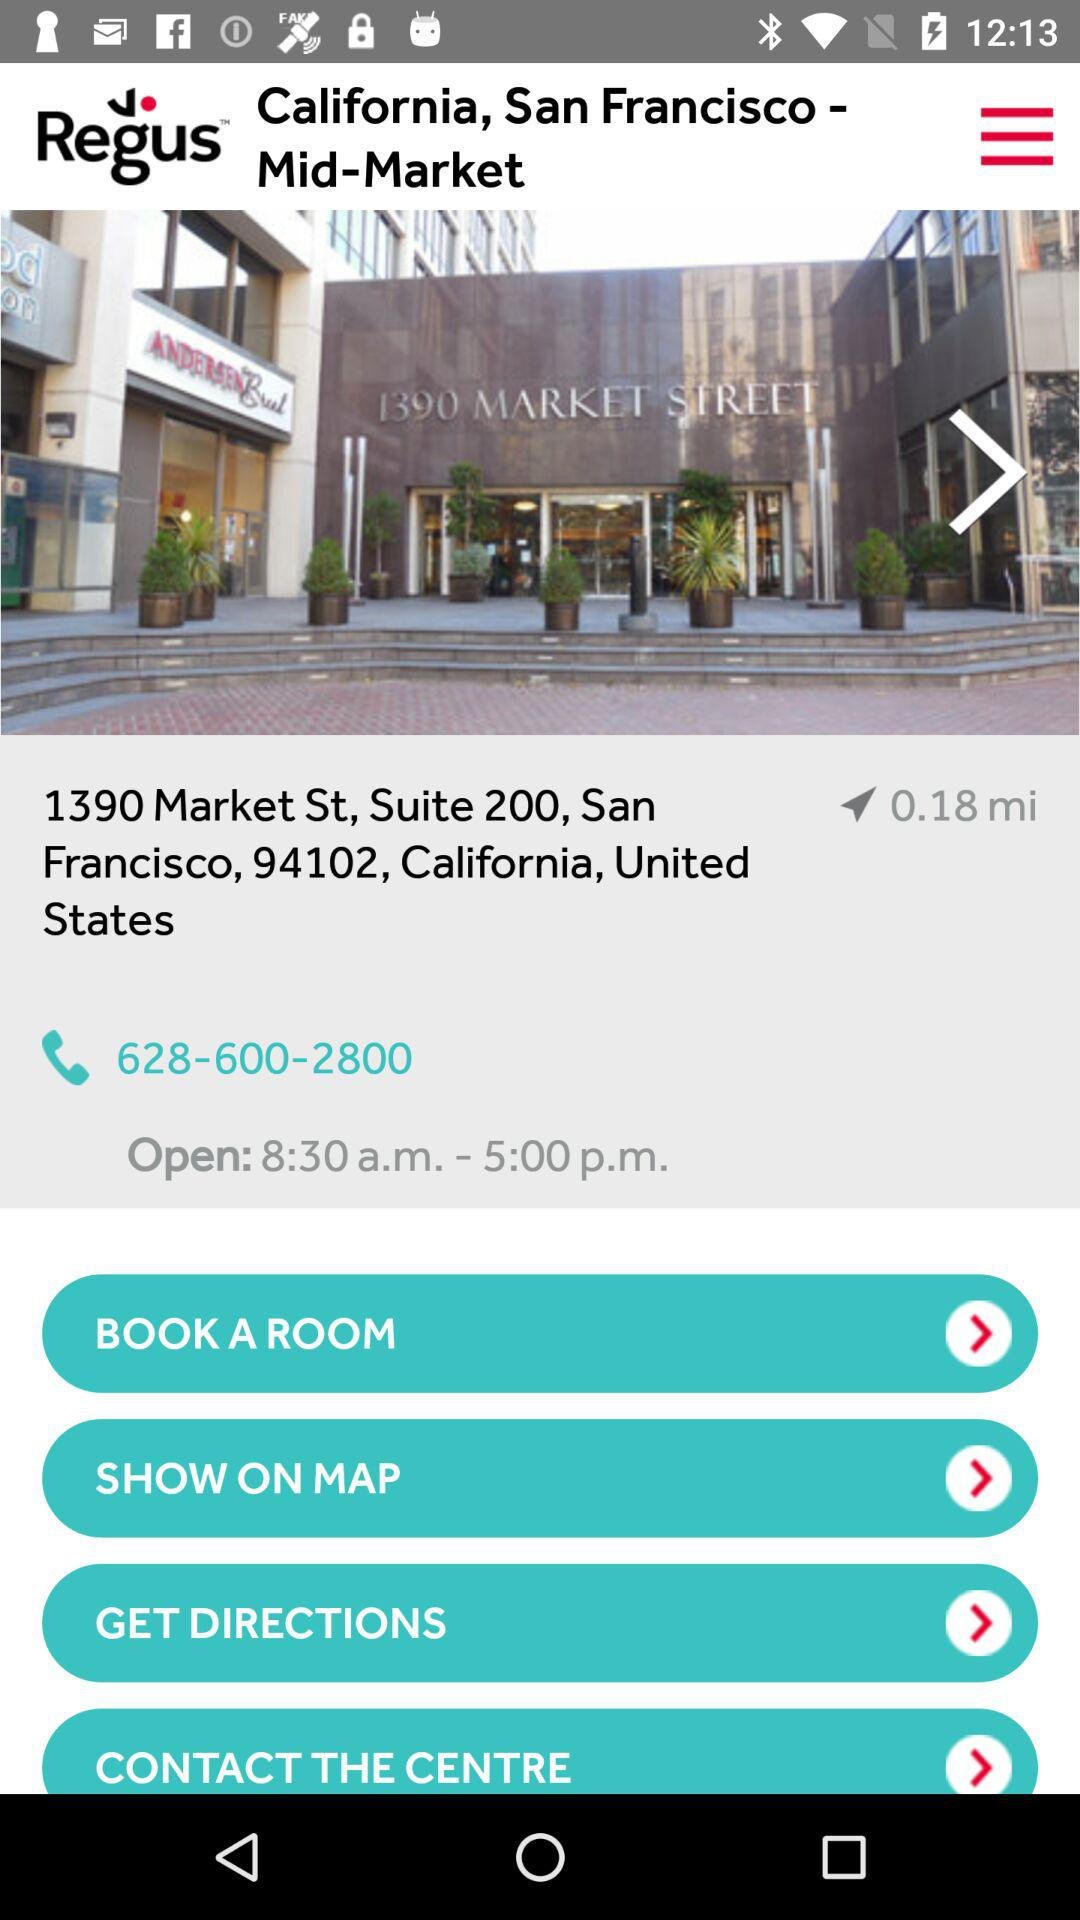What is the given phone number? The given phone number is 628-600-2800. 